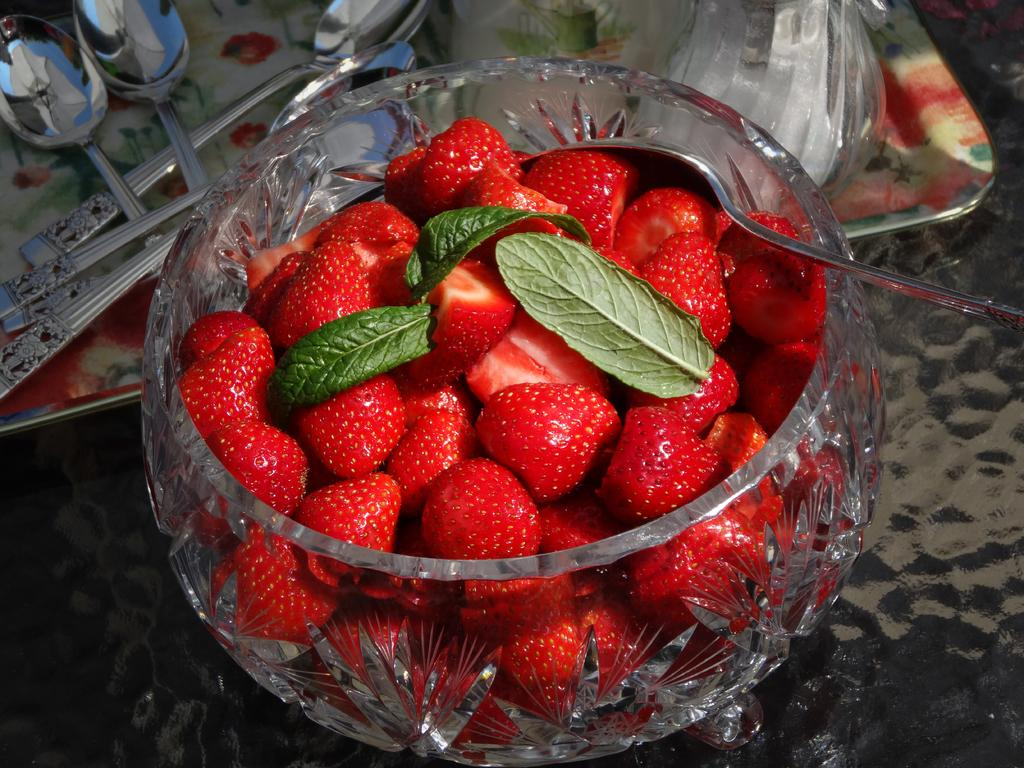What type of fruit can be seen in the image? There are strawberries in the image. What else is present in the image besides the strawberries? There are leaves in the image. What is the spoon doing in the glass object in the image? The spoon is in a glass object, which might be a container for the strawberries. What is the tray used for in the image? The tray is used to hold spoons and other objects in the image. How many women are present in the image? There are no women present in the image. What type of shoe can be seen in the image? There are no shoes present in the image. 